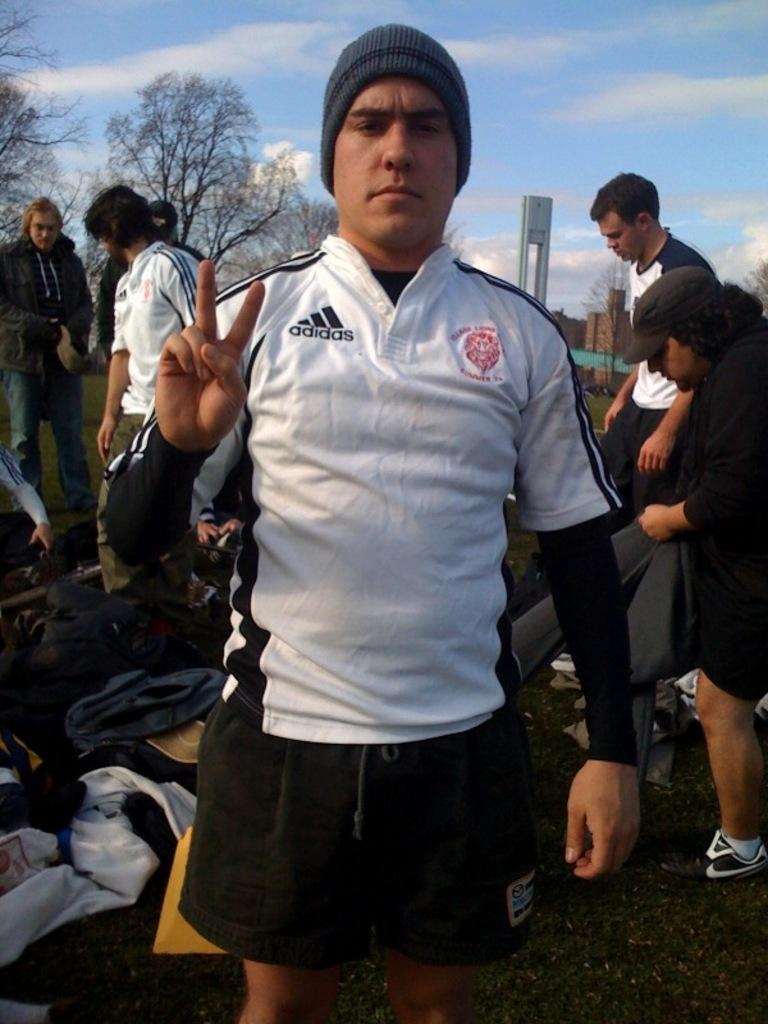<image>
Summarize the visual content of the image. A man wearing a white Adidas shirt ready to go on a trip. 